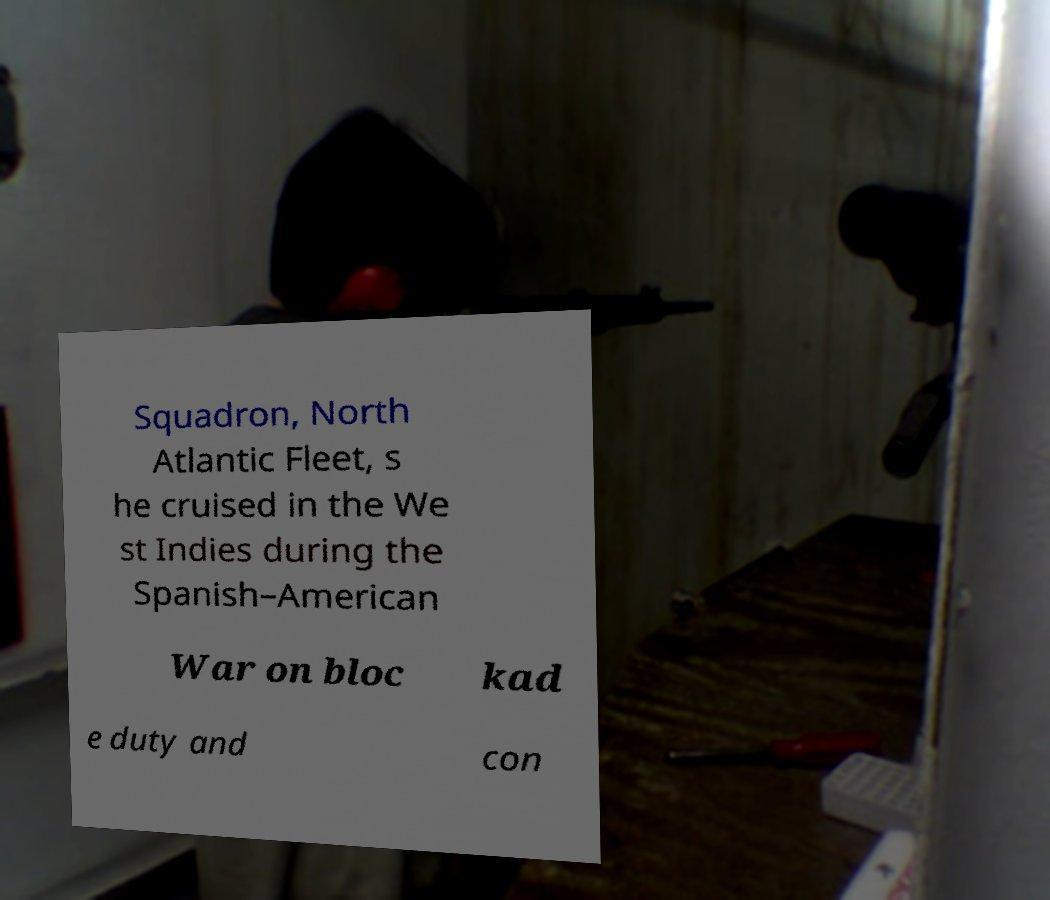What messages or text are displayed in this image? I need them in a readable, typed format. Squadron, North Atlantic Fleet, s he cruised in the We st Indies during the Spanish–American War on bloc kad e duty and con 